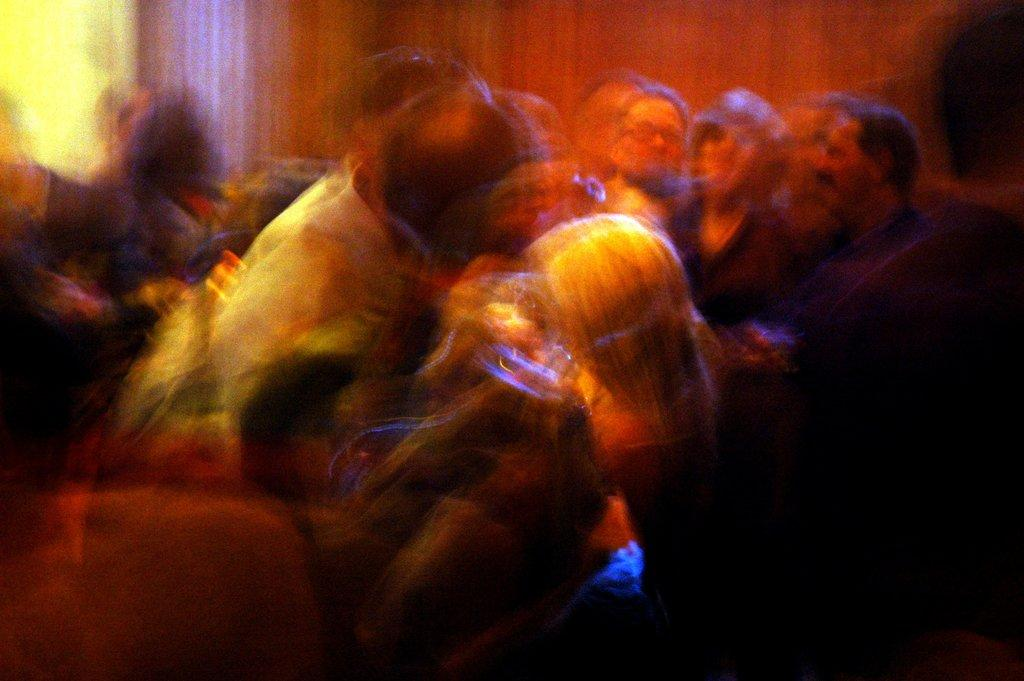What is the main setting of the image? There is a room in the image. How many people are present in the room? There are a lot of people in the room. Can you describe the quality of the images of the people? The images of the people are blurred and not clear. How many chairs are visible in the image? There is no mention of chairs in the provided facts, so it is impossible to determine the number of chairs in the image. 